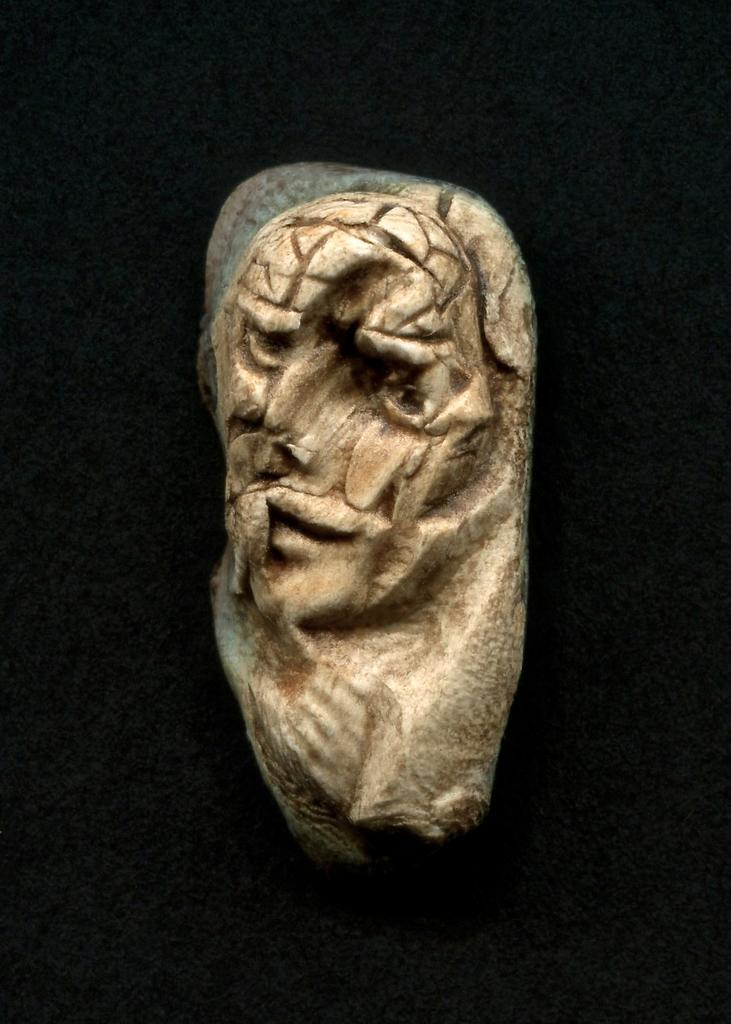What is the main subject of the image? There is a sculpture in the image. What color is the background of the image? The background of the image is black. What type of soap is being offered in the image? There is no soap or offering present in the image; it features a sculpture with a black background. 